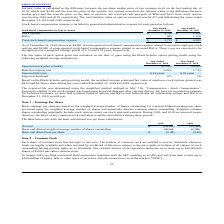According to Virnetx Holding's financial document, How was the expected life determined? Using the simplified method outlined in ASC 718, “Compensation - Stock Compensation”. The document states: "The expected life was determined using the simplified method outlined in ASC 718, “Compensation - Stock Compensation” . Expected volatility of the sto..." Also, How was the fair value of each option grant estimated? Using the Black-Scholes option pricing model. The document states: "h option grant was estimated on the date of grant using the Black-Scholes option pricing model using the following weighted average assumptions:..." Also, What is the risk-free interest rate in 2018? According to the financial document, 2.73%. The relevant text states: "Risk-free interest rate 2.09% 2.73%..." Also, can you calculate: What is the percentage change in the weighted average estimated fair value of employee stock options granted per share in 2019? To answer this question, I need to perform calculations using the financial data. The calculation is: (4.63-2.58)/2.58 , which equals 79.46 (percentage). This is based on the information: "of employee stock options granted was $4.63 and $2.58 per share during the years ended December 31, 2019 and 2018, respectively. fair value of employee stock options granted was $4.63 and $2.58 per sh..." The key data points involved are: 2.58, 4.63. Also, can you calculate: What was the change in the expected life term between 2018 and 2019? Based on the calculation: 6.14 - 6.02 , the result is 0.12. This is based on the information: "Expected life term 6.14 years 6.02 years Expected life term 6.14 years 6.02 years..." The key data points involved are: 6.02, 6.14. Additionally, Which year has a larger risk-free interest rate? According to the financial document, 2018. The relevant text states: "and $135 from stock options exercised in 2019 and 2018, respectively. The total intrinsic value of options exercised was $2,473 and $46 during the years e..." 